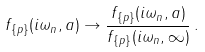<formula> <loc_0><loc_0><loc_500><loc_500>f _ { \{ p \} } ( i \omega _ { n } , a ) \to \frac { f _ { \{ p \} } ( i \omega _ { n } , a ) } { f _ { \{ p \} } ( i \omega _ { n } , \infty ) } \, { . }</formula> 